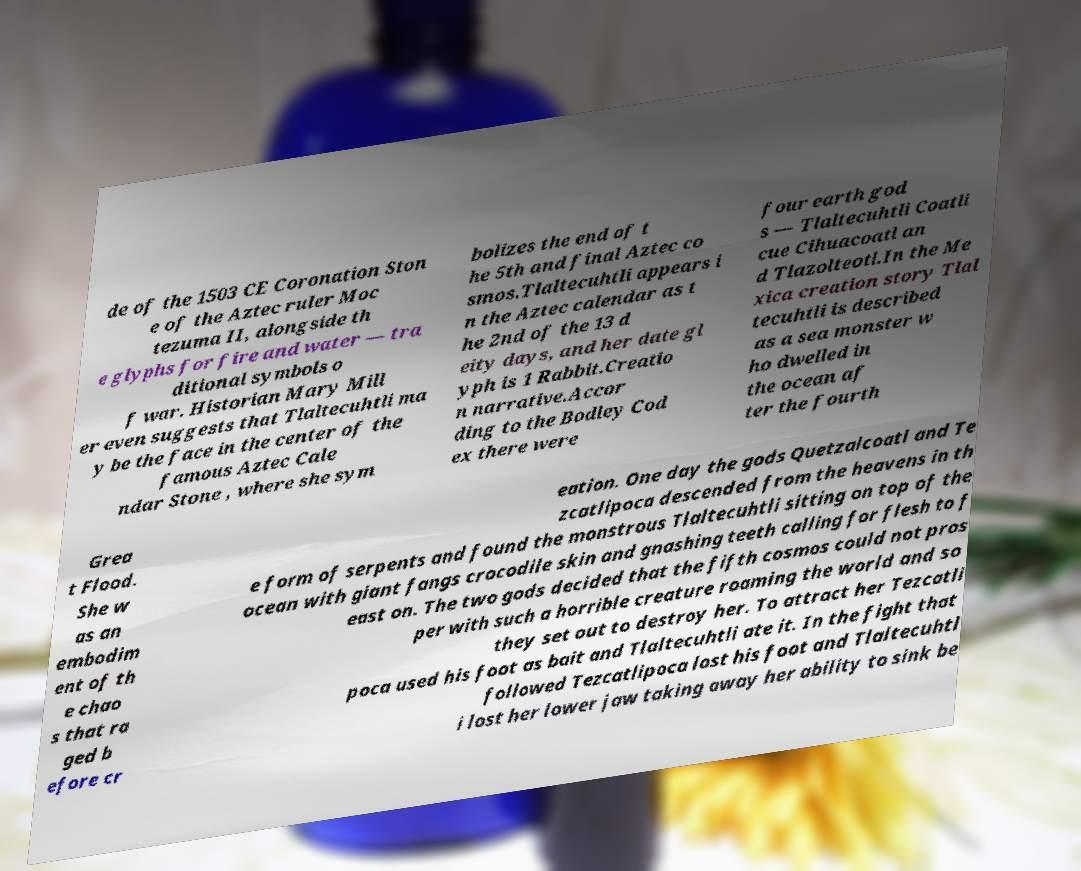Can you read and provide the text displayed in the image?This photo seems to have some interesting text. Can you extract and type it out for me? de of the 1503 CE Coronation Ston e of the Aztec ruler Moc tezuma II, alongside th e glyphs for fire and water — tra ditional symbols o f war. Historian Mary Mill er even suggests that Tlaltecuhtli ma y be the face in the center of the famous Aztec Cale ndar Stone , where she sym bolizes the end of t he 5th and final Aztec co smos.Tlaltecuhtli appears i n the Aztec calendar as t he 2nd of the 13 d eity days, and her date gl yph is 1 Rabbit.Creatio n narrative.Accor ding to the Bodley Cod ex there were four earth god s — Tlaltecuhtli Coatli cue Cihuacoatl an d Tlazolteotl.In the Me xica creation story Tlal tecuhtli is described as a sea monster w ho dwelled in the ocean af ter the fourth Grea t Flood. She w as an embodim ent of th e chao s that ra ged b efore cr eation. One day the gods Quetzalcoatl and Te zcatlipoca descended from the heavens in th e form of serpents and found the monstrous Tlaltecuhtli sitting on top of the ocean with giant fangs crocodile skin and gnashing teeth calling for flesh to f east on. The two gods decided that the fifth cosmos could not pros per with such a horrible creature roaming the world and so they set out to destroy her. To attract her Tezcatli poca used his foot as bait and Tlaltecuhtli ate it. In the fight that followed Tezcatlipoca lost his foot and Tlaltecuhtl i lost her lower jaw taking away her ability to sink be 